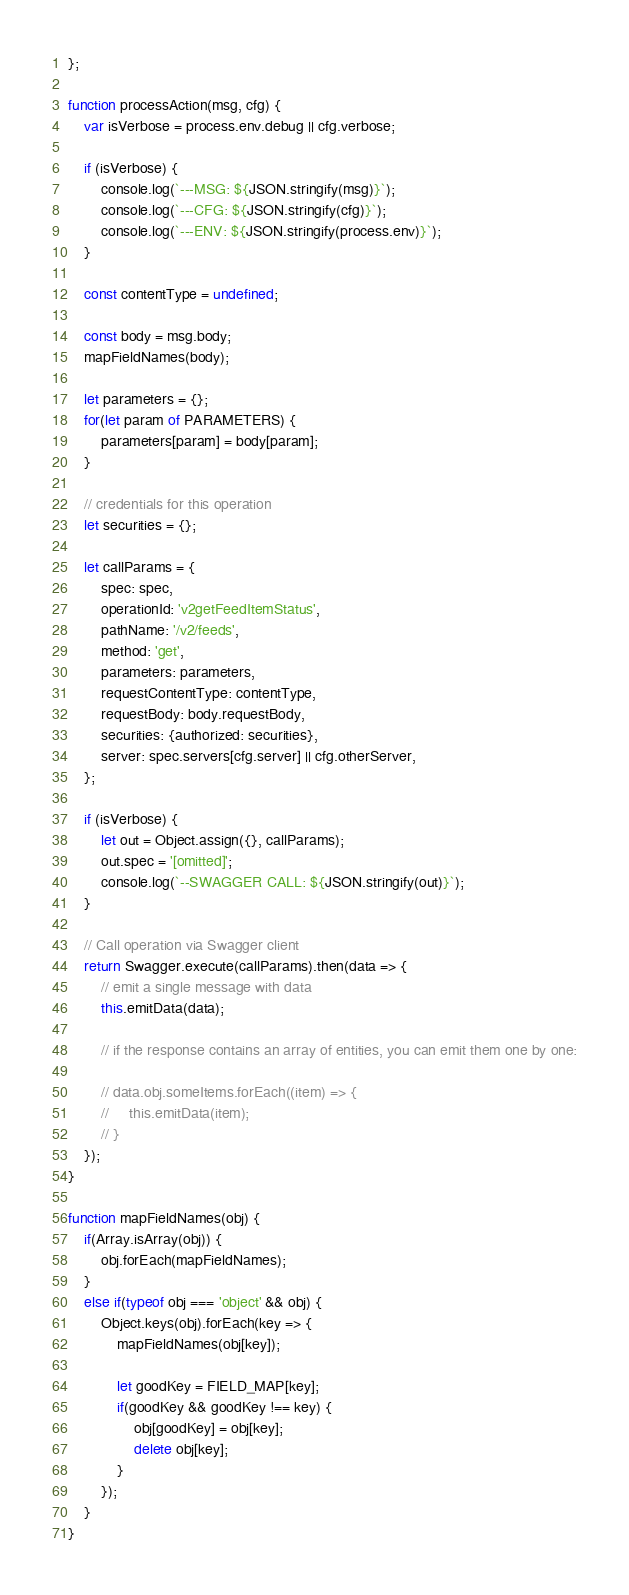<code> <loc_0><loc_0><loc_500><loc_500><_JavaScript_>};

function processAction(msg, cfg) {
    var isVerbose = process.env.debug || cfg.verbose;

    if (isVerbose) {
        console.log(`---MSG: ${JSON.stringify(msg)}`);
        console.log(`---CFG: ${JSON.stringify(cfg)}`);
        console.log(`---ENV: ${JSON.stringify(process.env)}`);
    }

    const contentType = undefined;

    const body = msg.body;
    mapFieldNames(body);

    let parameters = {};
    for(let param of PARAMETERS) {
        parameters[param] = body[param];
    }

    // credentials for this operation
    let securities = {};

    let callParams = {
        spec: spec,
        operationId: 'v2getFeedItemStatus',
        pathName: '/v2/feeds',
        method: 'get',
        parameters: parameters,
        requestContentType: contentType,
        requestBody: body.requestBody,
        securities: {authorized: securities},
        server: spec.servers[cfg.server] || cfg.otherServer,
    };

    if (isVerbose) {
        let out = Object.assign({}, callParams);
        out.spec = '[omitted]';
        console.log(`--SWAGGER CALL: ${JSON.stringify(out)}`);
    }

    // Call operation via Swagger client
    return Swagger.execute(callParams).then(data => {
        // emit a single message with data
        this.emitData(data);

        // if the response contains an array of entities, you can emit them one by one:

        // data.obj.someItems.forEach((item) => {
        //     this.emitData(item);
        // }
    });
}

function mapFieldNames(obj) {
    if(Array.isArray(obj)) {
        obj.forEach(mapFieldNames);
    }
    else if(typeof obj === 'object' && obj) {
        Object.keys(obj).forEach(key => {
            mapFieldNames(obj[key]);

            let goodKey = FIELD_MAP[key];
            if(goodKey && goodKey !== key) {
                obj[goodKey] = obj[key];
                delete obj[key];
            }
        });
    }
}</code> 